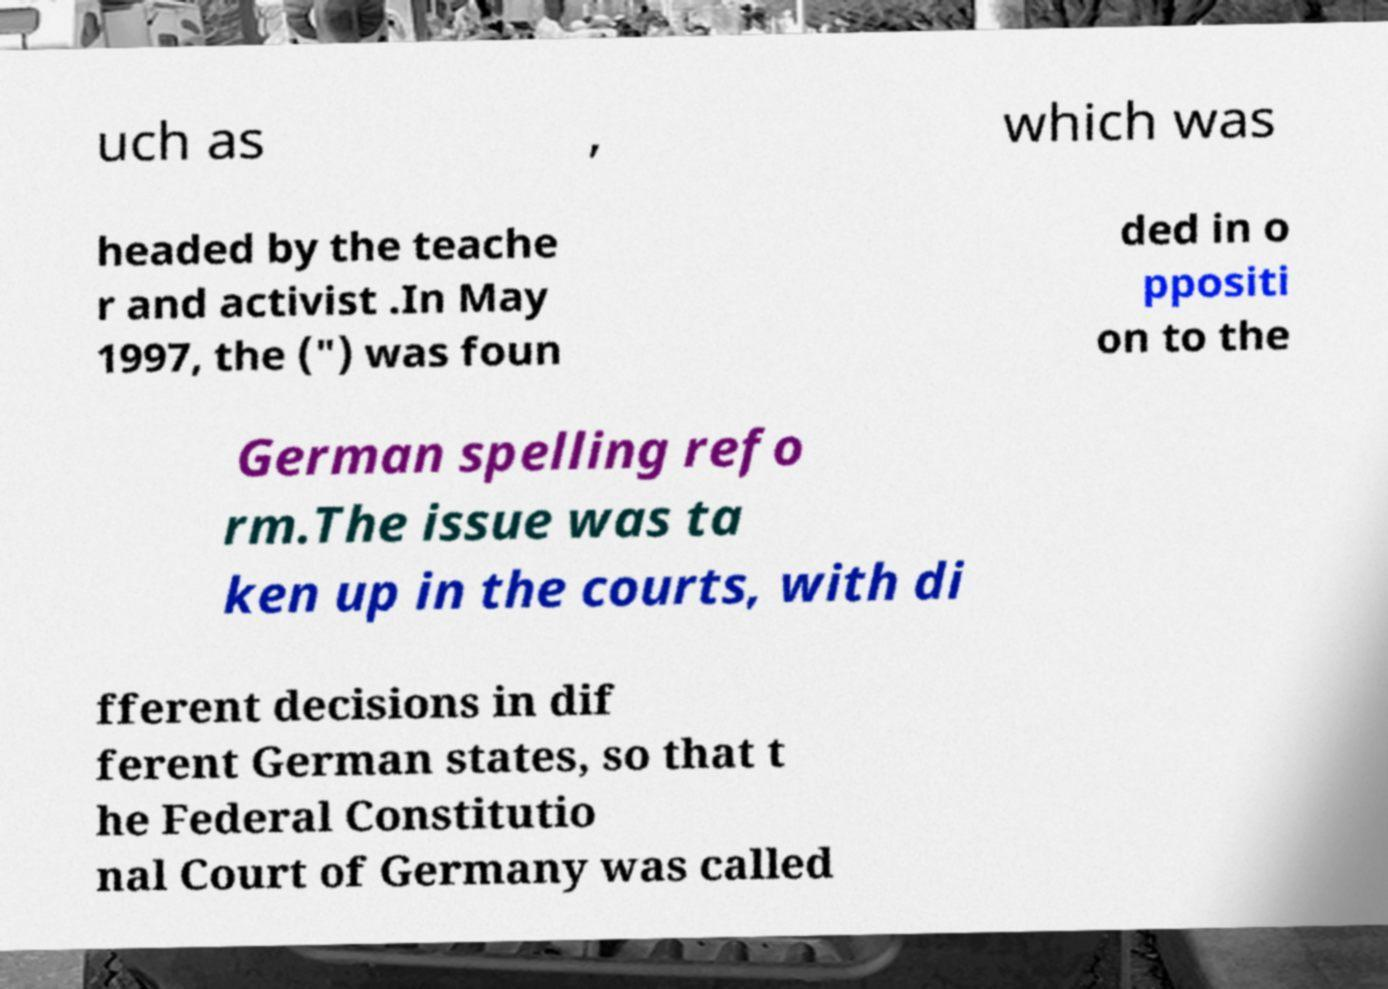Can you read and provide the text displayed in the image?This photo seems to have some interesting text. Can you extract and type it out for me? uch as , which was headed by the teache r and activist .In May 1997, the (") was foun ded in o ppositi on to the German spelling refo rm.The issue was ta ken up in the courts, with di fferent decisions in dif ferent German states, so that t he Federal Constitutio nal Court of Germany was called 